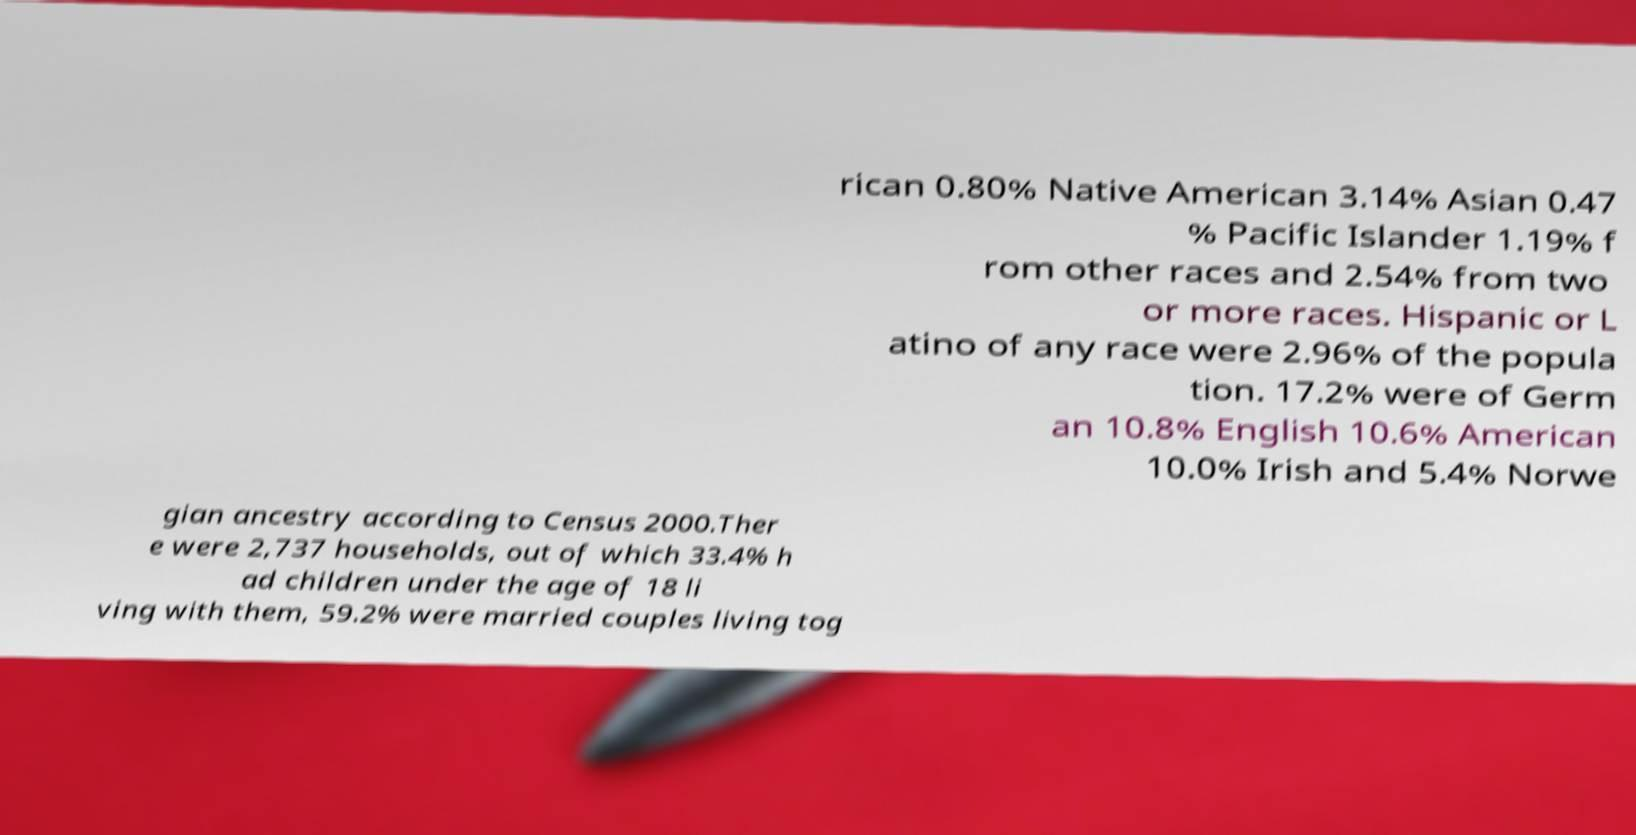Could you extract and type out the text from this image? rican 0.80% Native American 3.14% Asian 0.47 % Pacific Islander 1.19% f rom other races and 2.54% from two or more races. Hispanic or L atino of any race were 2.96% of the popula tion. 17.2% were of Germ an 10.8% English 10.6% American 10.0% Irish and 5.4% Norwe gian ancestry according to Census 2000.Ther e were 2,737 households, out of which 33.4% h ad children under the age of 18 li ving with them, 59.2% were married couples living tog 